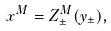Convert formula to latex. <formula><loc_0><loc_0><loc_500><loc_500>x ^ { M } = Z ^ { M } _ { \pm } ( y _ { \pm } ) ,</formula> 